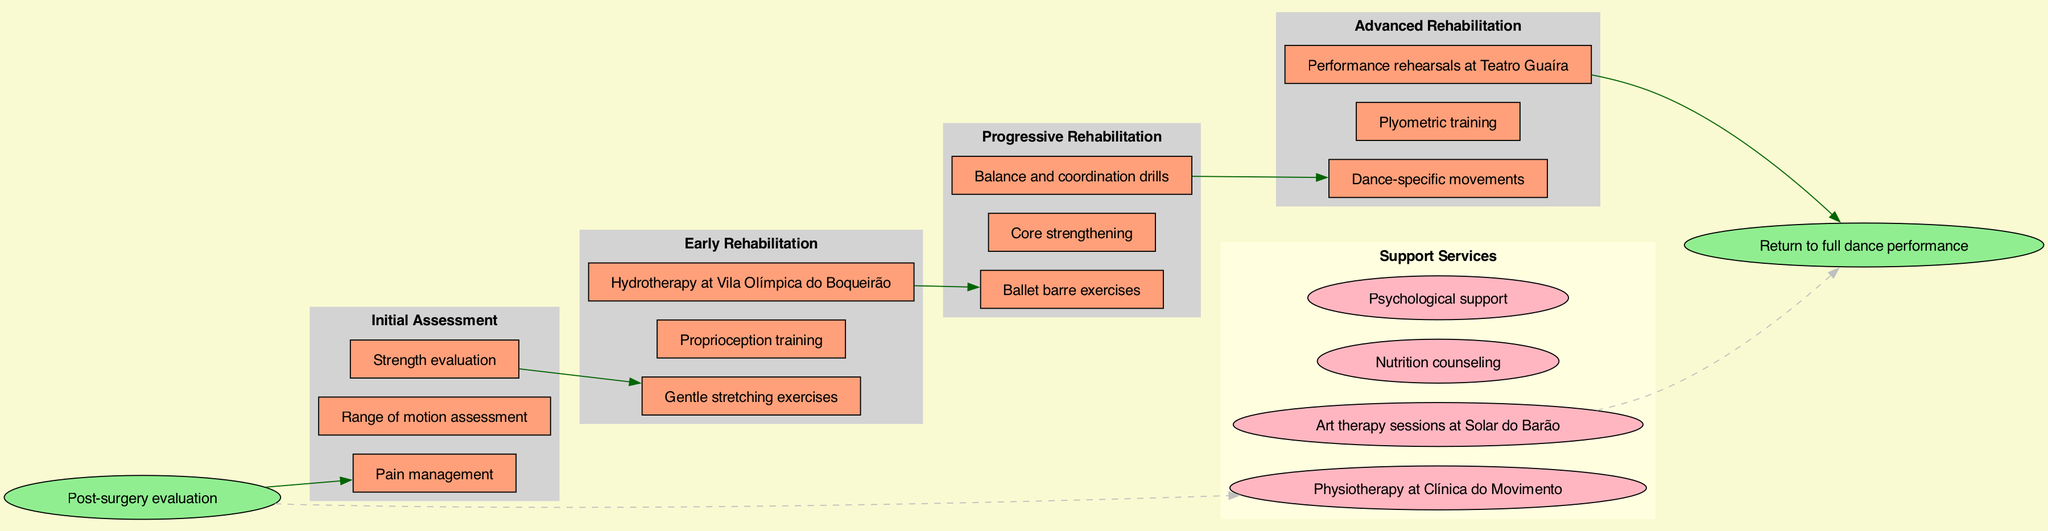What is the starting point of the clinical pathway? The diagram clearly states the starting point as "Post-surgery evaluation," which is labeled at the beginning of the flow.
Answer: Post-surgery evaluation How many stages are there in the rehabilitation process? By examining the stages listed in the diagram, we can count a total of four distinct stages: Initial Assessment, Early Rehabilitation, Progressive Rehabilitation, and Advanced Rehabilitation.
Answer: 4 What activity is included in the Early Rehabilitation stage? Looking at the activities under the Early Rehabilitation stage, "Gentle stretching exercises" is one of the activities mentioned within that section.
Answer: Gentle stretching exercises Which support service is specifically located at Solar do Barão? The diagram identifies "Art therapy sessions at Solar do Barão" as one of the support services, clearly associating that location with a specific therapy service.
Answer: Art therapy sessions at Solar do Barão What activity signifies the final stage before reaching the endpoint? In the Advanced Rehabilitation stage, the final activity listed is "Performance rehearsals at Teatro Guaíra," which is crucial just before the endpoint is reached.
Answer: Performance rehearsals at Teatro Guaíra What does the endpoint of the clinical pathway signify? The endpoint, labeled as "Return to full dance performance," illustrates the ultimate goal of the rehabilitation process, highlighting what the entire pathway aims to achieve.
Answer: Return to full dance performance Which stage comes after Initial Assessment? According to the diagram, the stage that follows the Initial Assessment is the Early Rehabilitation stage, which is the second step in the rehabilitation process.
Answer: Early Rehabilitation How many support services are listed in the diagram? By reviewing the support services outlined, we can identify that there are four services listed that provide additional assistance during the rehabilitation process.
Answer: 4 